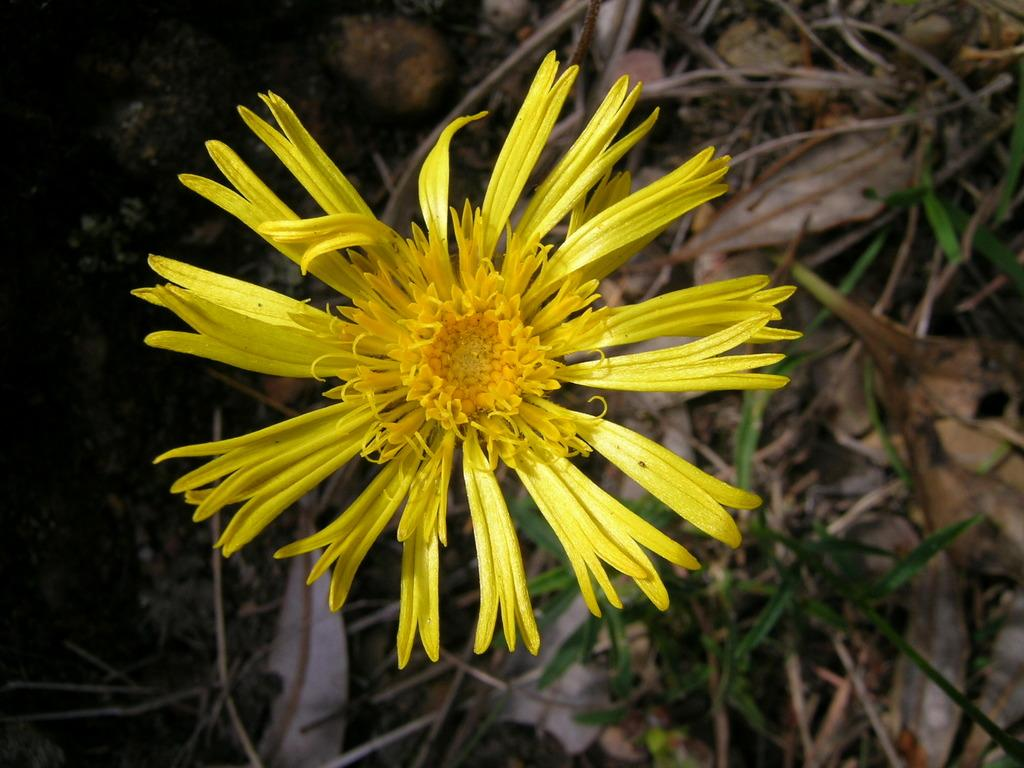What type of plant can be seen in the image? There is a flower in the image. What is the condition of the leaves on the plant? Dried leaves are present in the image. Are there any other plants visible in the image? Yes, there are plants in the image. What type of pest can be seen crawling on the church in the image? There is no church present in the image, and therefore no pest can be observed. 